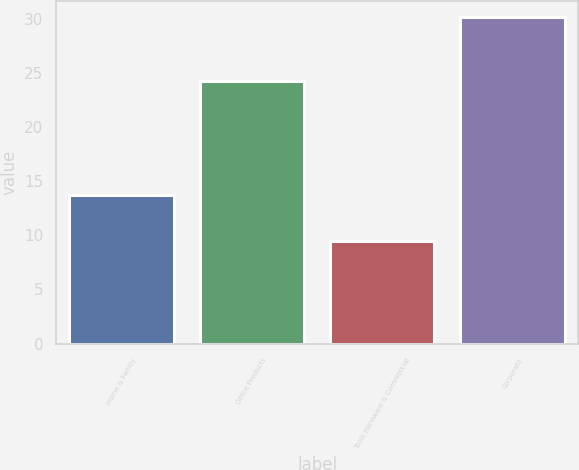Convert chart. <chart><loc_0><loc_0><loc_500><loc_500><bar_chart><fcel>Home & Family<fcel>Office Products<fcel>Tools Hardware & Commercial<fcel>Corporate<nl><fcel>13.7<fcel>24.2<fcel>9.5<fcel>30.1<nl></chart> 